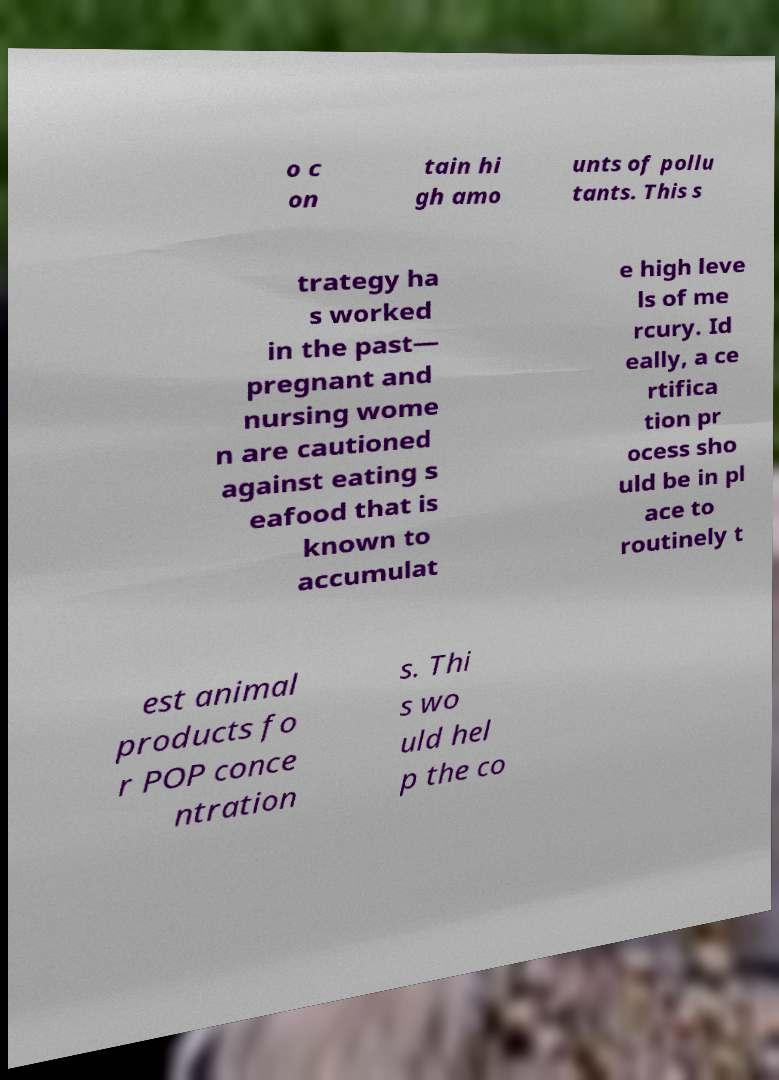There's text embedded in this image that I need extracted. Can you transcribe it verbatim? o c on tain hi gh amo unts of pollu tants. This s trategy ha s worked in the past— pregnant and nursing wome n are cautioned against eating s eafood that is known to accumulat e high leve ls of me rcury. Id eally, a ce rtifica tion pr ocess sho uld be in pl ace to routinely t est animal products fo r POP conce ntration s. Thi s wo uld hel p the co 